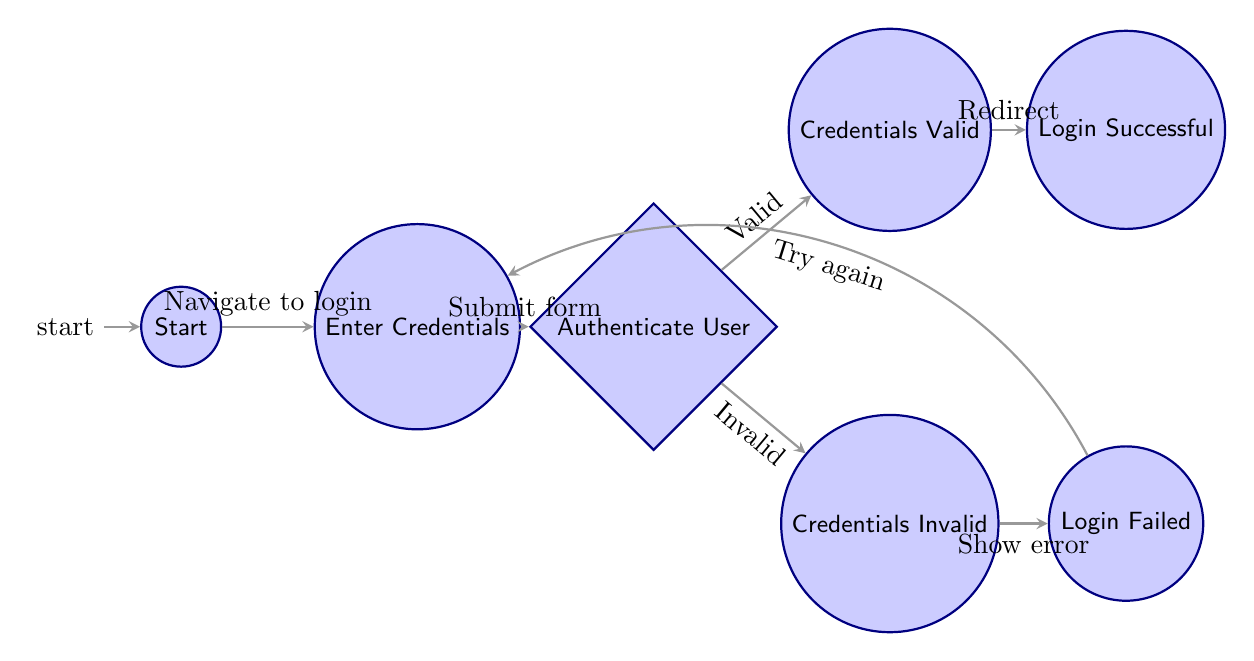What is the initial state when the user opens the application? The initial state is where no user interaction has occurred, which is labeled as "Start" in the diagram.
Answer: Start How many total states are present in the diagram? By counting the states, there are a total of 7 states represented in the diagram: Start, Enter Credentials, Authenticate User, Credentials Valid, Credentials Invalid, Login Successful, and Login Failed.
Answer: 7 What is the transition from the 'Start' state? From the 'Start' state, the transition occurs to the 'Enter Credentials' state when the user navigates to the login page.
Answer: Enter Credentials Which state indicates successful login? The state that indicates a successful login is labeled "Login Successful" in the diagram.
Answer: Login Successful What happens after the user enters invalid credentials? After entering invalid credentials, the user is shown an error message and prompted to enter credentials again, transitioning to the "Login Failed" state.
Answer: Login Failed In which state does the user enter their login information? The user enters their login information in the "Enter Credentials" state.
Answer: Enter Credentials From which state does the transition to 'Login Successful' occur? The transition to the 'Login Successful' state occurs from the 'Credentials Valid' state when the user is logged in and redirected.
Answer: Credentials Valid What is the condition for transitioning to 'Credentials Invalid'? The condition for transitioning to 'Credentials Invalid' is that the credentials submitted by the user are incorrect.
Answer: Credentials are incorrect Which state leads the user back to entering credentials after a failed login attempt? After a failed login attempt, the user is led back to the "Enter Credentials" state to try again.
Answer: Enter Credentials 